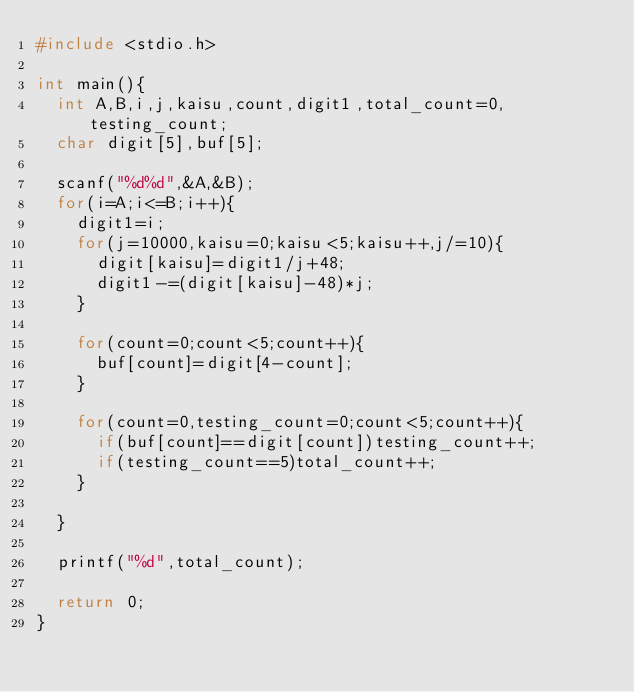Convert code to text. <code><loc_0><loc_0><loc_500><loc_500><_C_>#include <stdio.h>

int main(){
  int A,B,i,j,kaisu,count,digit1,total_count=0,testing_count;
  char digit[5],buf[5];

  scanf("%d%d",&A,&B);
  for(i=A;i<=B;i++){
    digit1=i;
    for(j=10000,kaisu=0;kaisu<5;kaisu++,j/=10){
      digit[kaisu]=digit1/j+48;
      digit1-=(digit[kaisu]-48)*j;
    }

    for(count=0;count<5;count++){
      buf[count]=digit[4-count];
    }

    for(count=0,testing_count=0;count<5;count++){
      if(buf[count]==digit[count])testing_count++;
      if(testing_count==5)total_count++;
    }

  }

  printf("%d",total_count);

  return 0;
}
</code> 